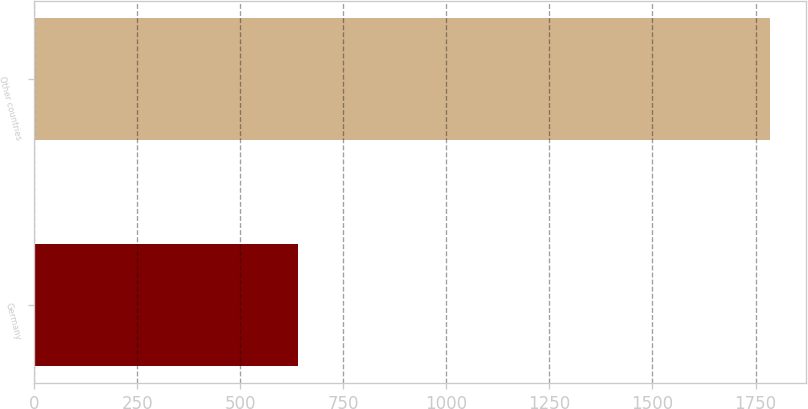<chart> <loc_0><loc_0><loc_500><loc_500><bar_chart><fcel>Germany<fcel>Other countries<nl><fcel>640<fcel>1784<nl></chart> 